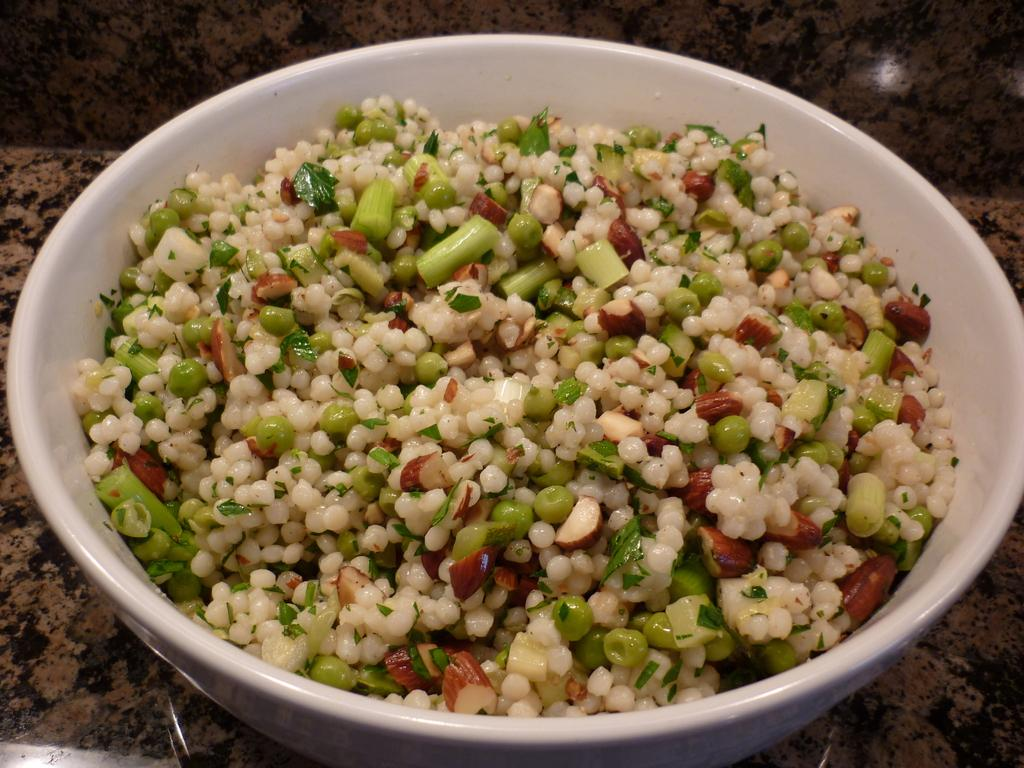What is in the bowl that is visible in the image? There is a bowl with food in the image. Where is the bowl located in the image? The bowl is placed on a counter. What suggestions can be found in the books on the counter in the image? There are no books present in the image, so there are no suggestions to be found. 